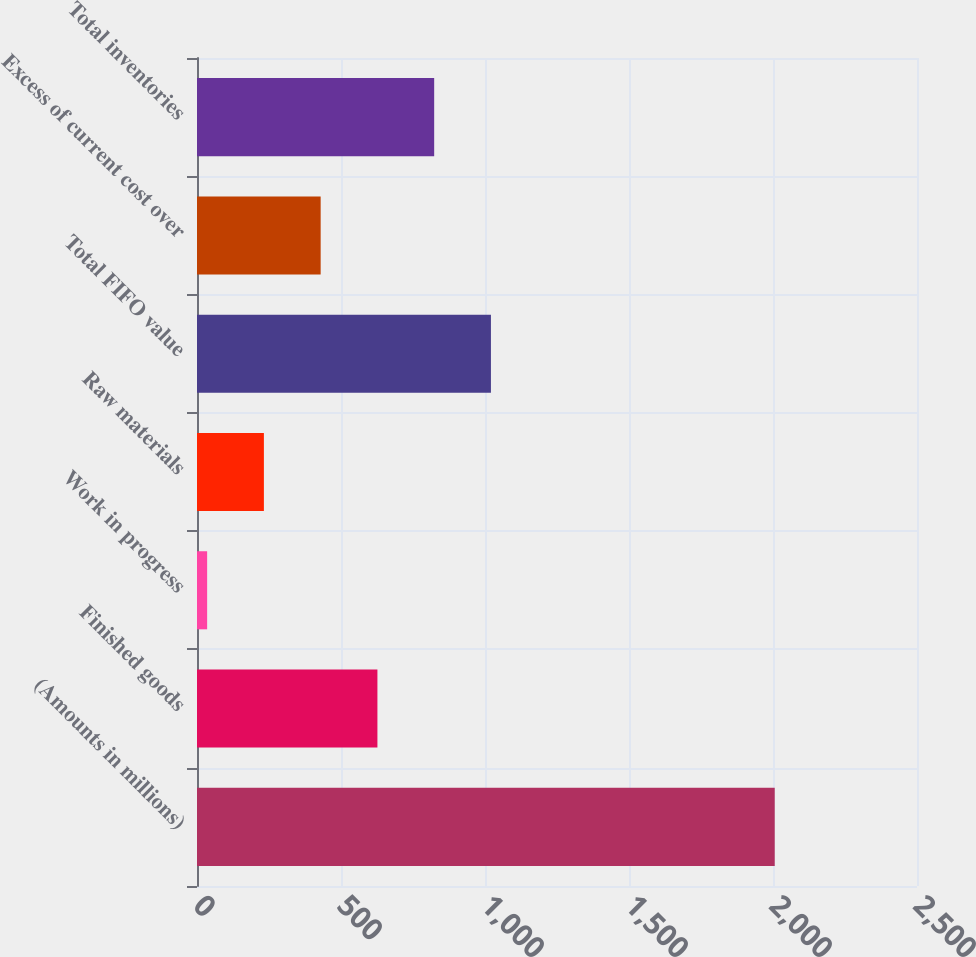Convert chart to OTSL. <chart><loc_0><loc_0><loc_500><loc_500><bar_chart><fcel>(Amounts in millions)<fcel>Finished goods<fcel>Work in progress<fcel>Raw materials<fcel>Total FIFO value<fcel>Excess of current cost over<fcel>Total inventories<nl><fcel>2006<fcel>626.44<fcel>35.2<fcel>232.28<fcel>1020.6<fcel>429.36<fcel>823.52<nl></chart> 